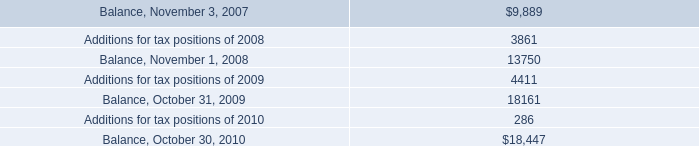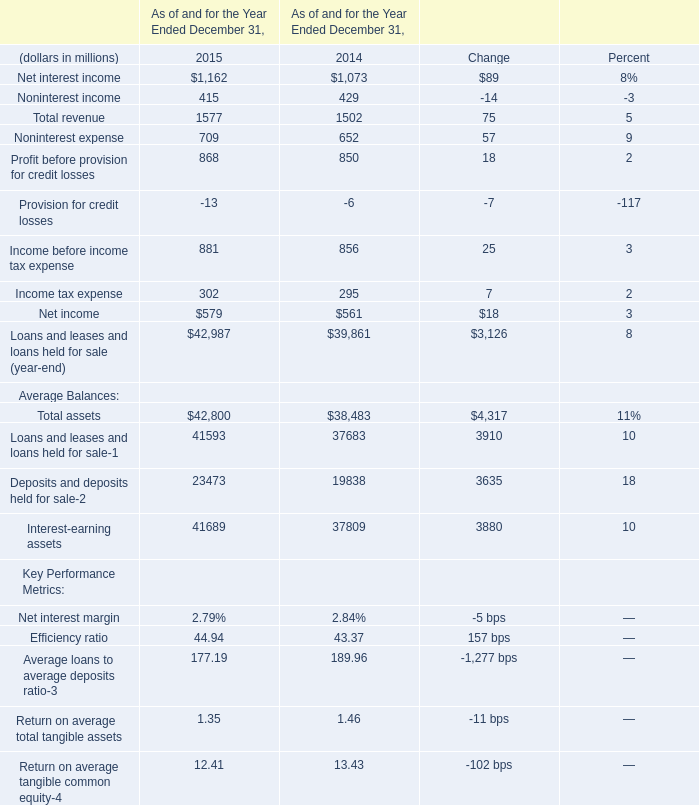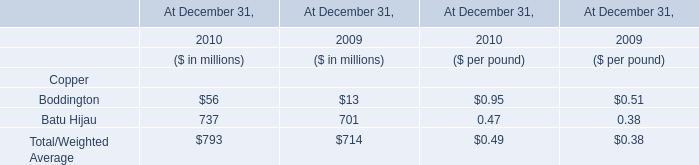What is the sum of Net interest income, Noninterest income and Noninterest expense in 2015 ? (in million) 
Computations: ((1162 + 415) + 709)
Answer: 2286.0. 